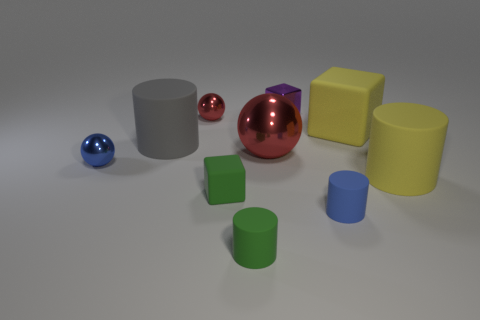Subtract all cylinders. How many objects are left? 6 Add 9 large gray shiny cylinders. How many large gray shiny cylinders exist? 9 Subtract 0 green balls. How many objects are left? 10 Subtract all tiny red metal balls. Subtract all blue spheres. How many objects are left? 8 Add 3 yellow objects. How many yellow objects are left? 5 